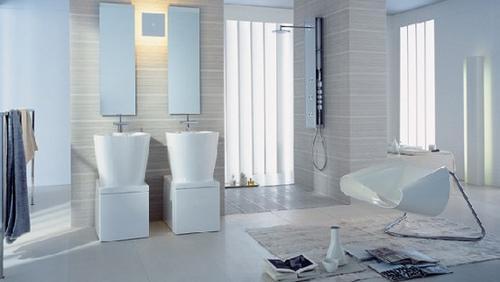How many sinks are in the picture?
Give a very brief answer. 2. 